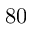Convert formula to latex. <formula><loc_0><loc_0><loc_500><loc_500>8 0</formula> 